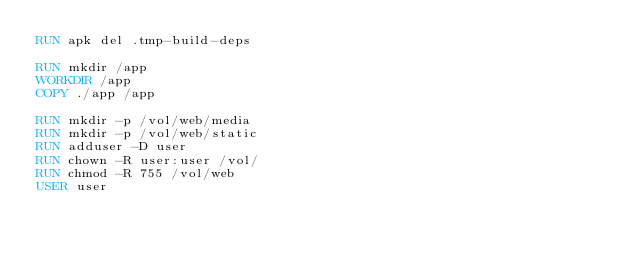<code> <loc_0><loc_0><loc_500><loc_500><_Dockerfile_>RUN apk del .tmp-build-deps

RUN mkdir /app
WORKDIR /app
COPY ./app /app

RUN mkdir -p /vol/web/media
RUN mkdir -p /vol/web/static
RUN adduser -D user
RUN chown -R user:user /vol/
RUN chmod -R 755 /vol/web
USER user
</code> 